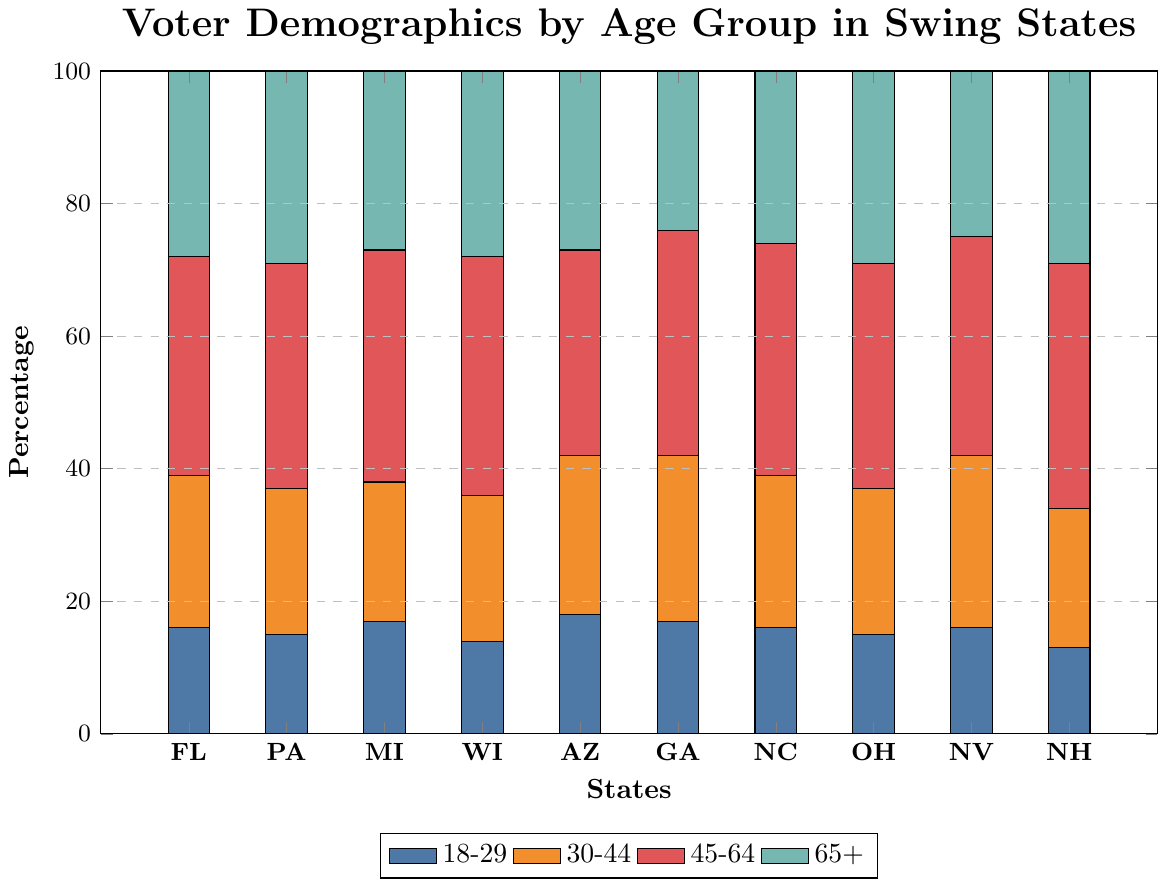What's the percentage of voters aged 45-64 in Georgia? Look at the bar for Georgia (GA) and focus on the section for 45-64 age group. It's the red section and the value is 34%.
Answer: 34% Which state has the highest percentage of voters aged 30-44? Compare the orange sections in all the states. Nevada has the highest percentage at 26%.
Answer: Nevada Which state has the lowest percentage of voters aged 18-29? Compare the blue sections in all the states. New Hampshire has the lowest percentage at 13%.
Answer: New Hampshire What’s the combined percentage of voters aged 18-29 and 65+ in Florida? Find the values for 18-29 and 65+ in Florida: 16% and 28%. Add them together: 16 + 28 = 44%.
Answer: 44% Is the percentage of voters aged 45-64 in Michigan higher than in Ohio? Compare the red sections for Michigan and Ohio. Michigan has 35% and Ohio has 34%. Yes, Michigan is higher.
Answer: Yes What is the average percentage of voters aged 65+ across all states? Sum the 65+ values across all states: 28 + 29 + 27 + 28 + 27 + 24 + 26 + 29 + 25 + 29 = 272. Divide by 10 (number of states): 272 / 10 = 27.2%.
Answer: 27.2% Which age group has the highest average percentage across all states? Sum the percentages for each age group and divide by 10. 
- 18-29: (16+15+17+14+18+17+16+15+16+13) / 10 = 15.7 
- 30-44: (23+22+21+22+24+25+23+22+26+21) / 10 = 22.9 
- 45-64: (33+34+35+36+31+34+35+34+33+37) / 10 = 34.2 
- 65+: (28+29+27+28+27+24+26+29+25+29) / 10 = 27.2 
Hence, the age group 45-64 has the highest average.
Answer: 45-64 What’s the difference in percentage of voters aged 30-44 between Florida and Georgia? Find the values for 30-44 in Florida and Georgia: 23% and 25%. Calculate the difference: 25 - 23 = 2%
Answer: 2% In which state do voters aged 65+ form exactly 28% of the electorate? Look for the states where 65+ section equals 28%. Florida and Wisconsin both show 28%.
Answer: Florida, Wisconsin 